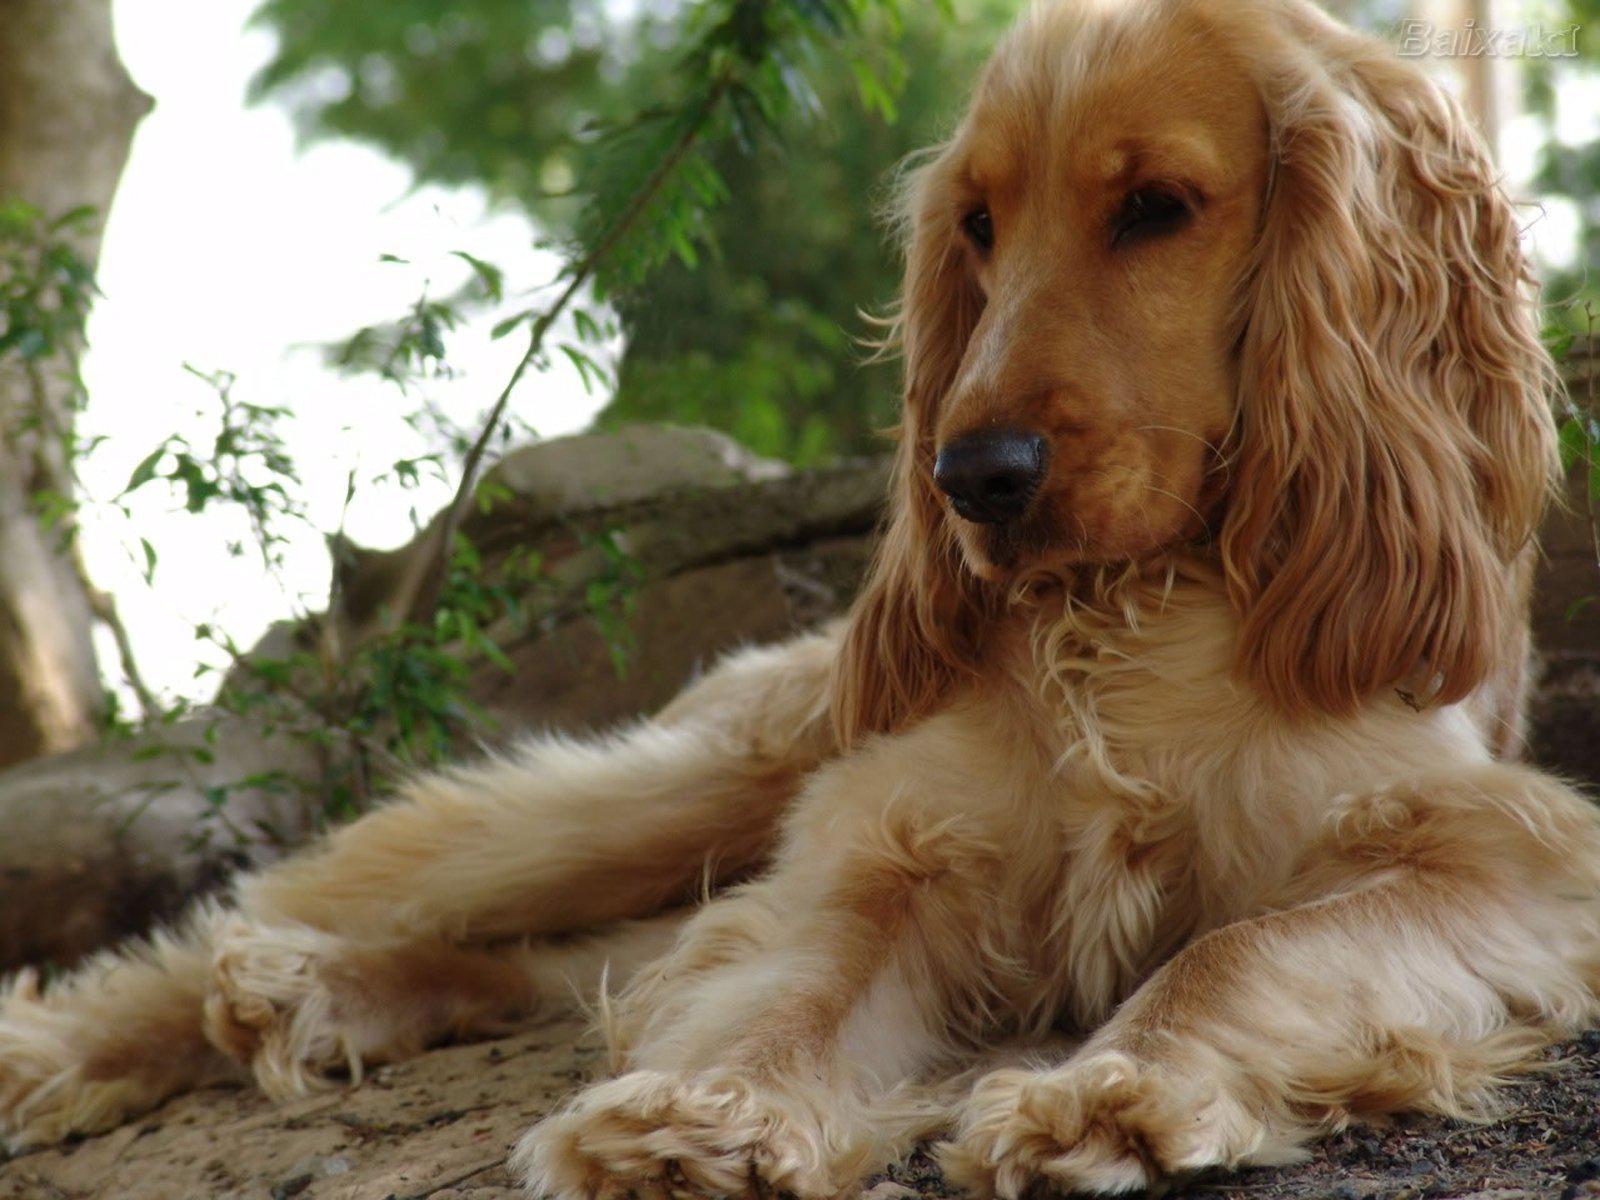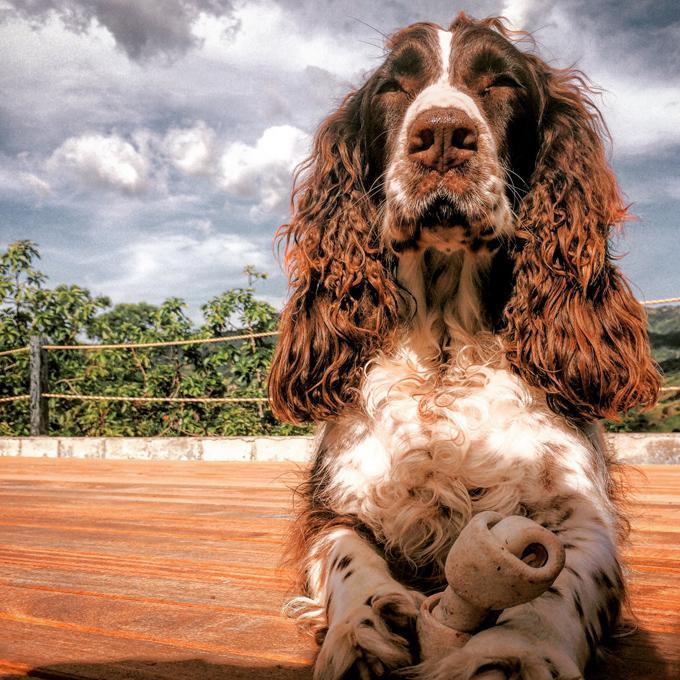The first image is the image on the left, the second image is the image on the right. For the images shown, is this caption "An image shows a gold-colored puppy with at least one paw draped over something." true? Answer yes or no. No. 